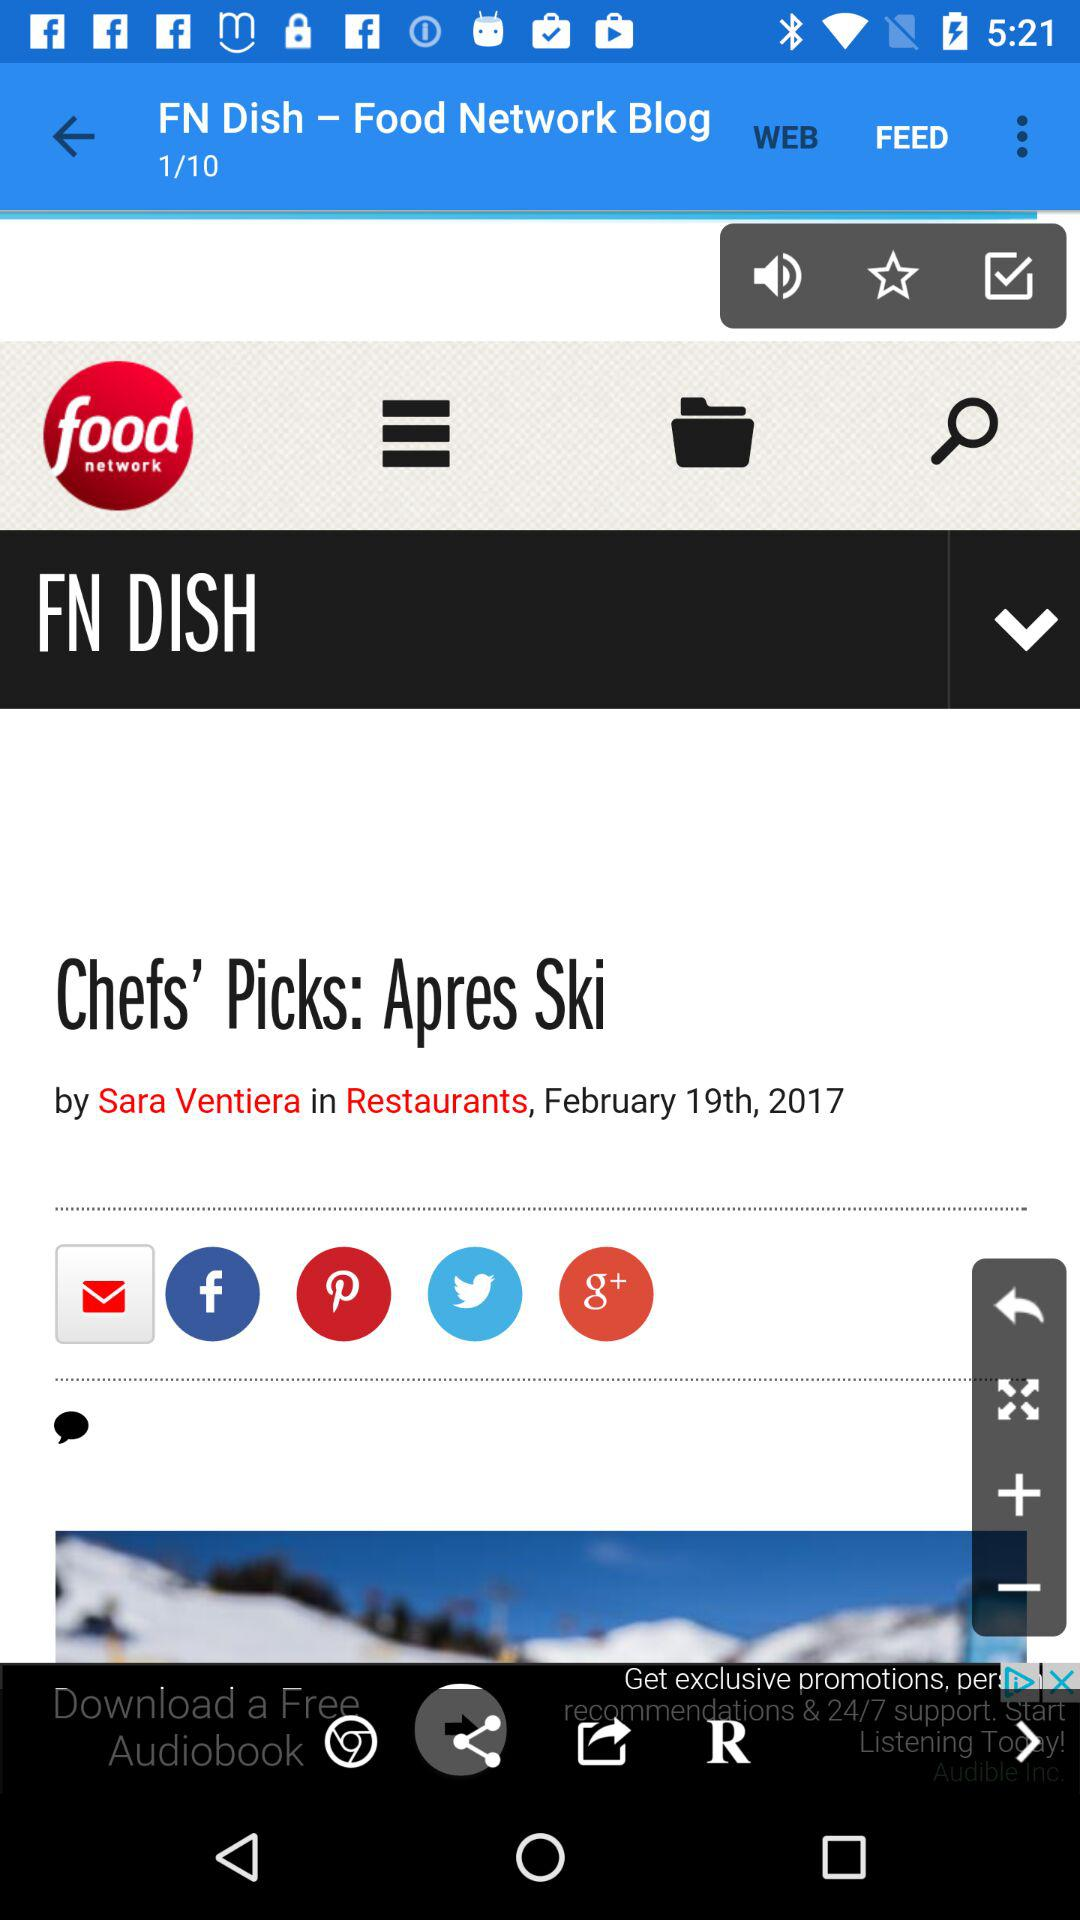Through which application can it be shared? It can be shared through "Facebook", "Pinterest", "Twitter" and "Google+". 